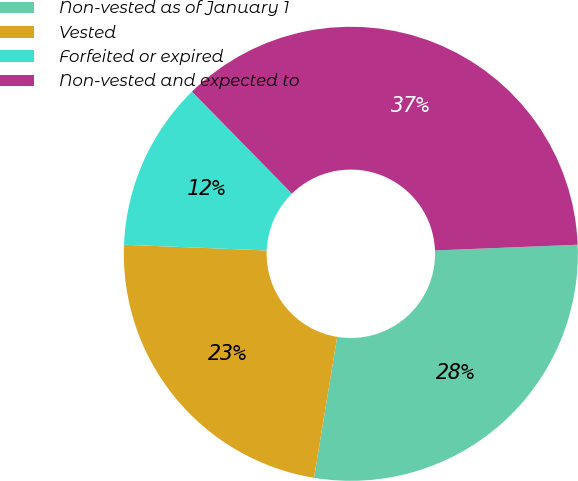<chart> <loc_0><loc_0><loc_500><loc_500><pie_chart><fcel>Non-vested as of January 1<fcel>Vested<fcel>Forfeited or expired<fcel>Non-vested and expected to<nl><fcel>28.23%<fcel>23.04%<fcel>12.03%<fcel>36.7%<nl></chart> 